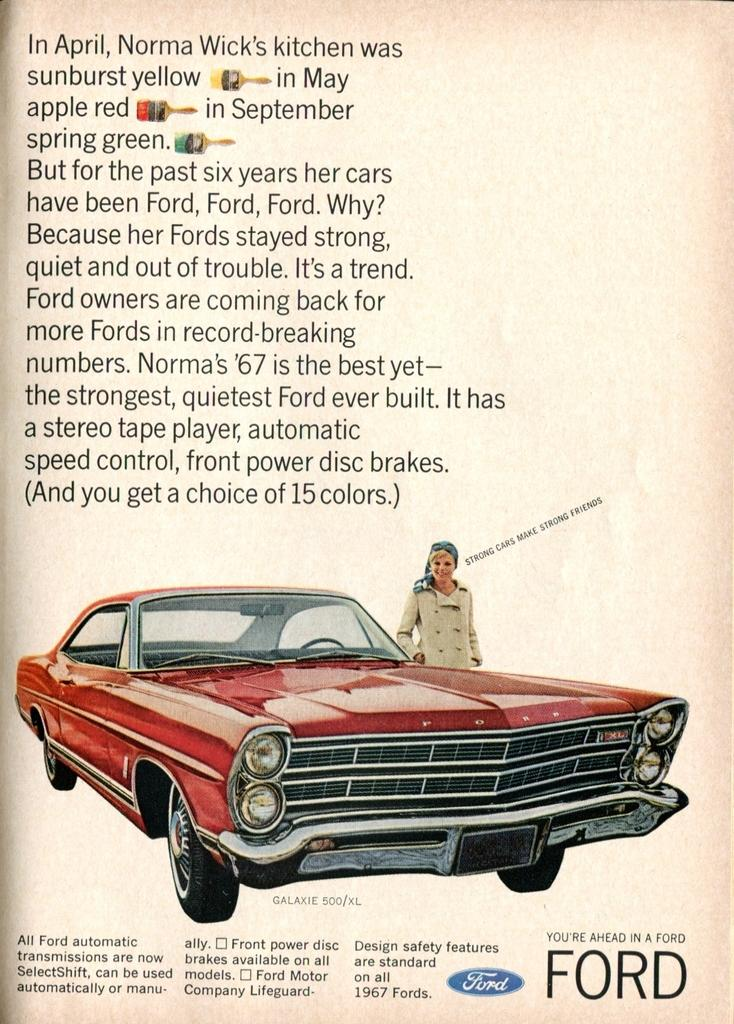What is present in the image that contains visual information? There is a poster in the image. What types of visual elements can be found on the poster? The poster contains pictures and text. What type of drink is being served on the poster? There is no drink present on the poster; it contains pictures and text. Can you tell me how many drums are featured in the poster? There are no drums present in the poster; it contains pictures and text. 